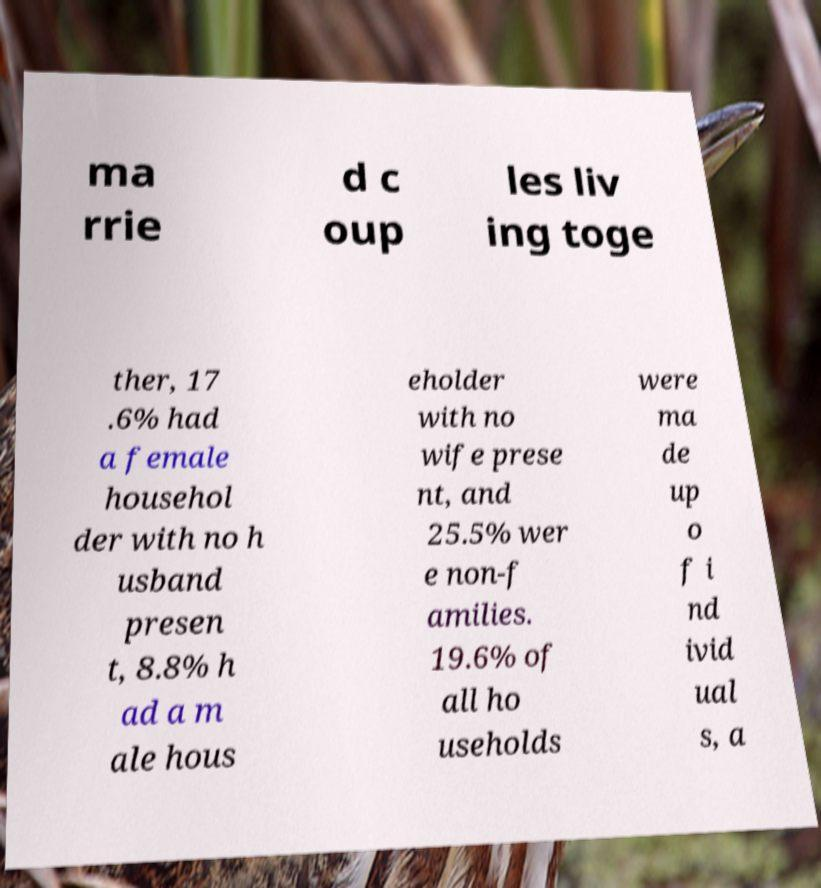Could you assist in decoding the text presented in this image and type it out clearly? ma rrie d c oup les liv ing toge ther, 17 .6% had a female househol der with no h usband presen t, 8.8% h ad a m ale hous eholder with no wife prese nt, and 25.5% wer e non-f amilies. 19.6% of all ho useholds were ma de up o f i nd ivid ual s, a 